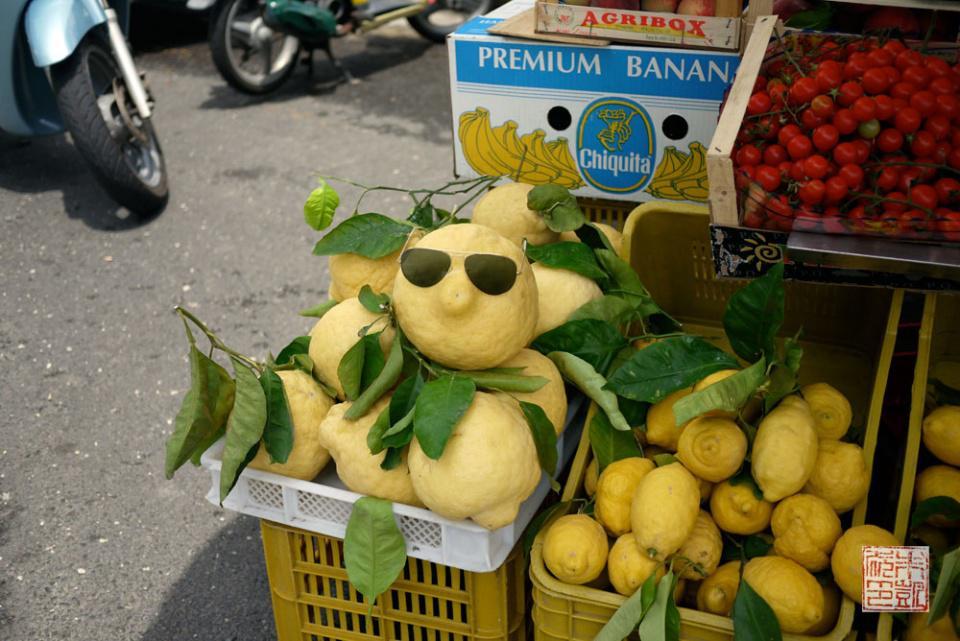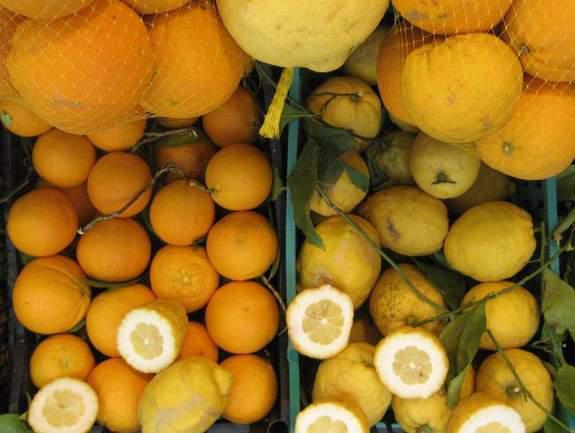The first image is the image on the left, the second image is the image on the right. Given the left and right images, does the statement "The left image includes a yellow plastic basket containing large yellow dimpled fruits, some with green leaves attached." hold true? Answer yes or no. Yes. The first image is the image on the left, the second image is the image on the right. Considering the images on both sides, is "In at least one image there are no more then four lemons with leaves under them" valid? Answer yes or no. No. 